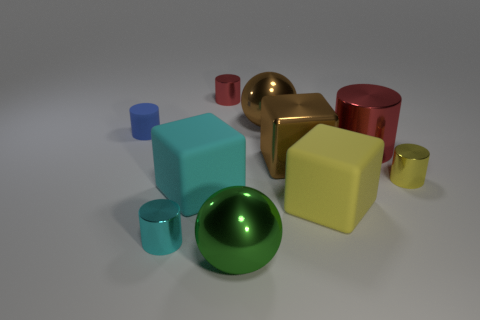Is the number of red cylinders that are to the left of the brown block the same as the number of rubber cylinders to the left of the tiny matte object?
Offer a very short reply. No. There is a red shiny cylinder that is right of the large thing that is behind the tiny blue rubber cylinder; what size is it?
Your answer should be compact. Large. Are there any green spheres of the same size as the blue object?
Your response must be concise. No. The cube that is the same material as the big red cylinder is what color?
Provide a succinct answer. Brown. Is the number of tiny yellow metallic cylinders less than the number of things?
Keep it short and to the point. Yes. There is a small cylinder that is behind the big cyan object and left of the large cyan object; what material is it made of?
Give a very brief answer. Rubber. There is a brown metal object behind the big red cylinder; are there any big brown shiny balls that are right of it?
Offer a terse response. No. How many large spheres have the same color as the shiny cube?
Give a very brief answer. 1. There is a large sphere that is the same color as the large shiny block; what is it made of?
Ensure brevity in your answer.  Metal. Is the material of the big cyan thing the same as the tiny blue cylinder?
Keep it short and to the point. Yes. 